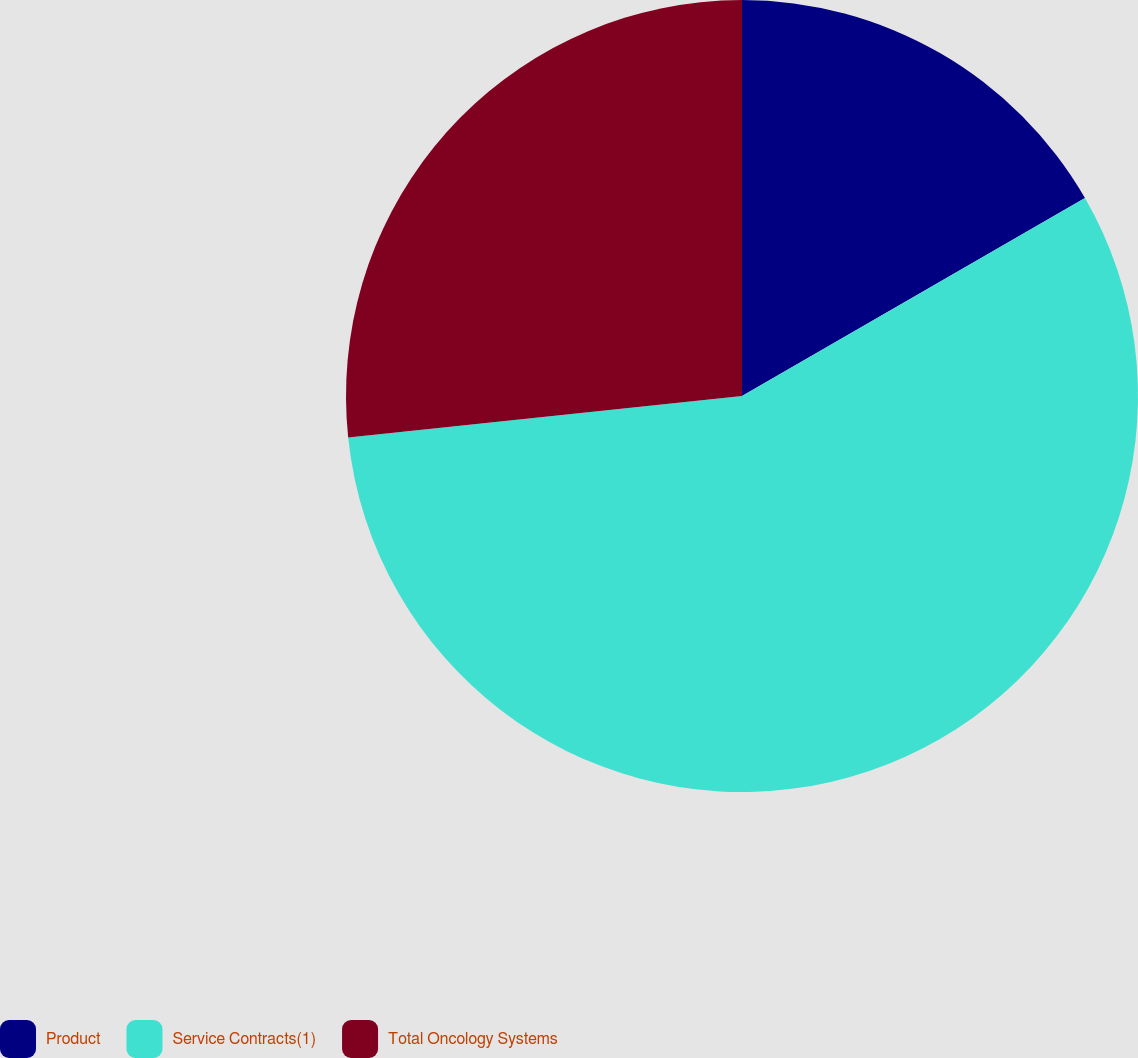Convert chart. <chart><loc_0><loc_0><loc_500><loc_500><pie_chart><fcel>Product<fcel>Service Contracts(1)<fcel>Total Oncology Systems<nl><fcel>16.67%<fcel>56.67%<fcel>26.67%<nl></chart> 